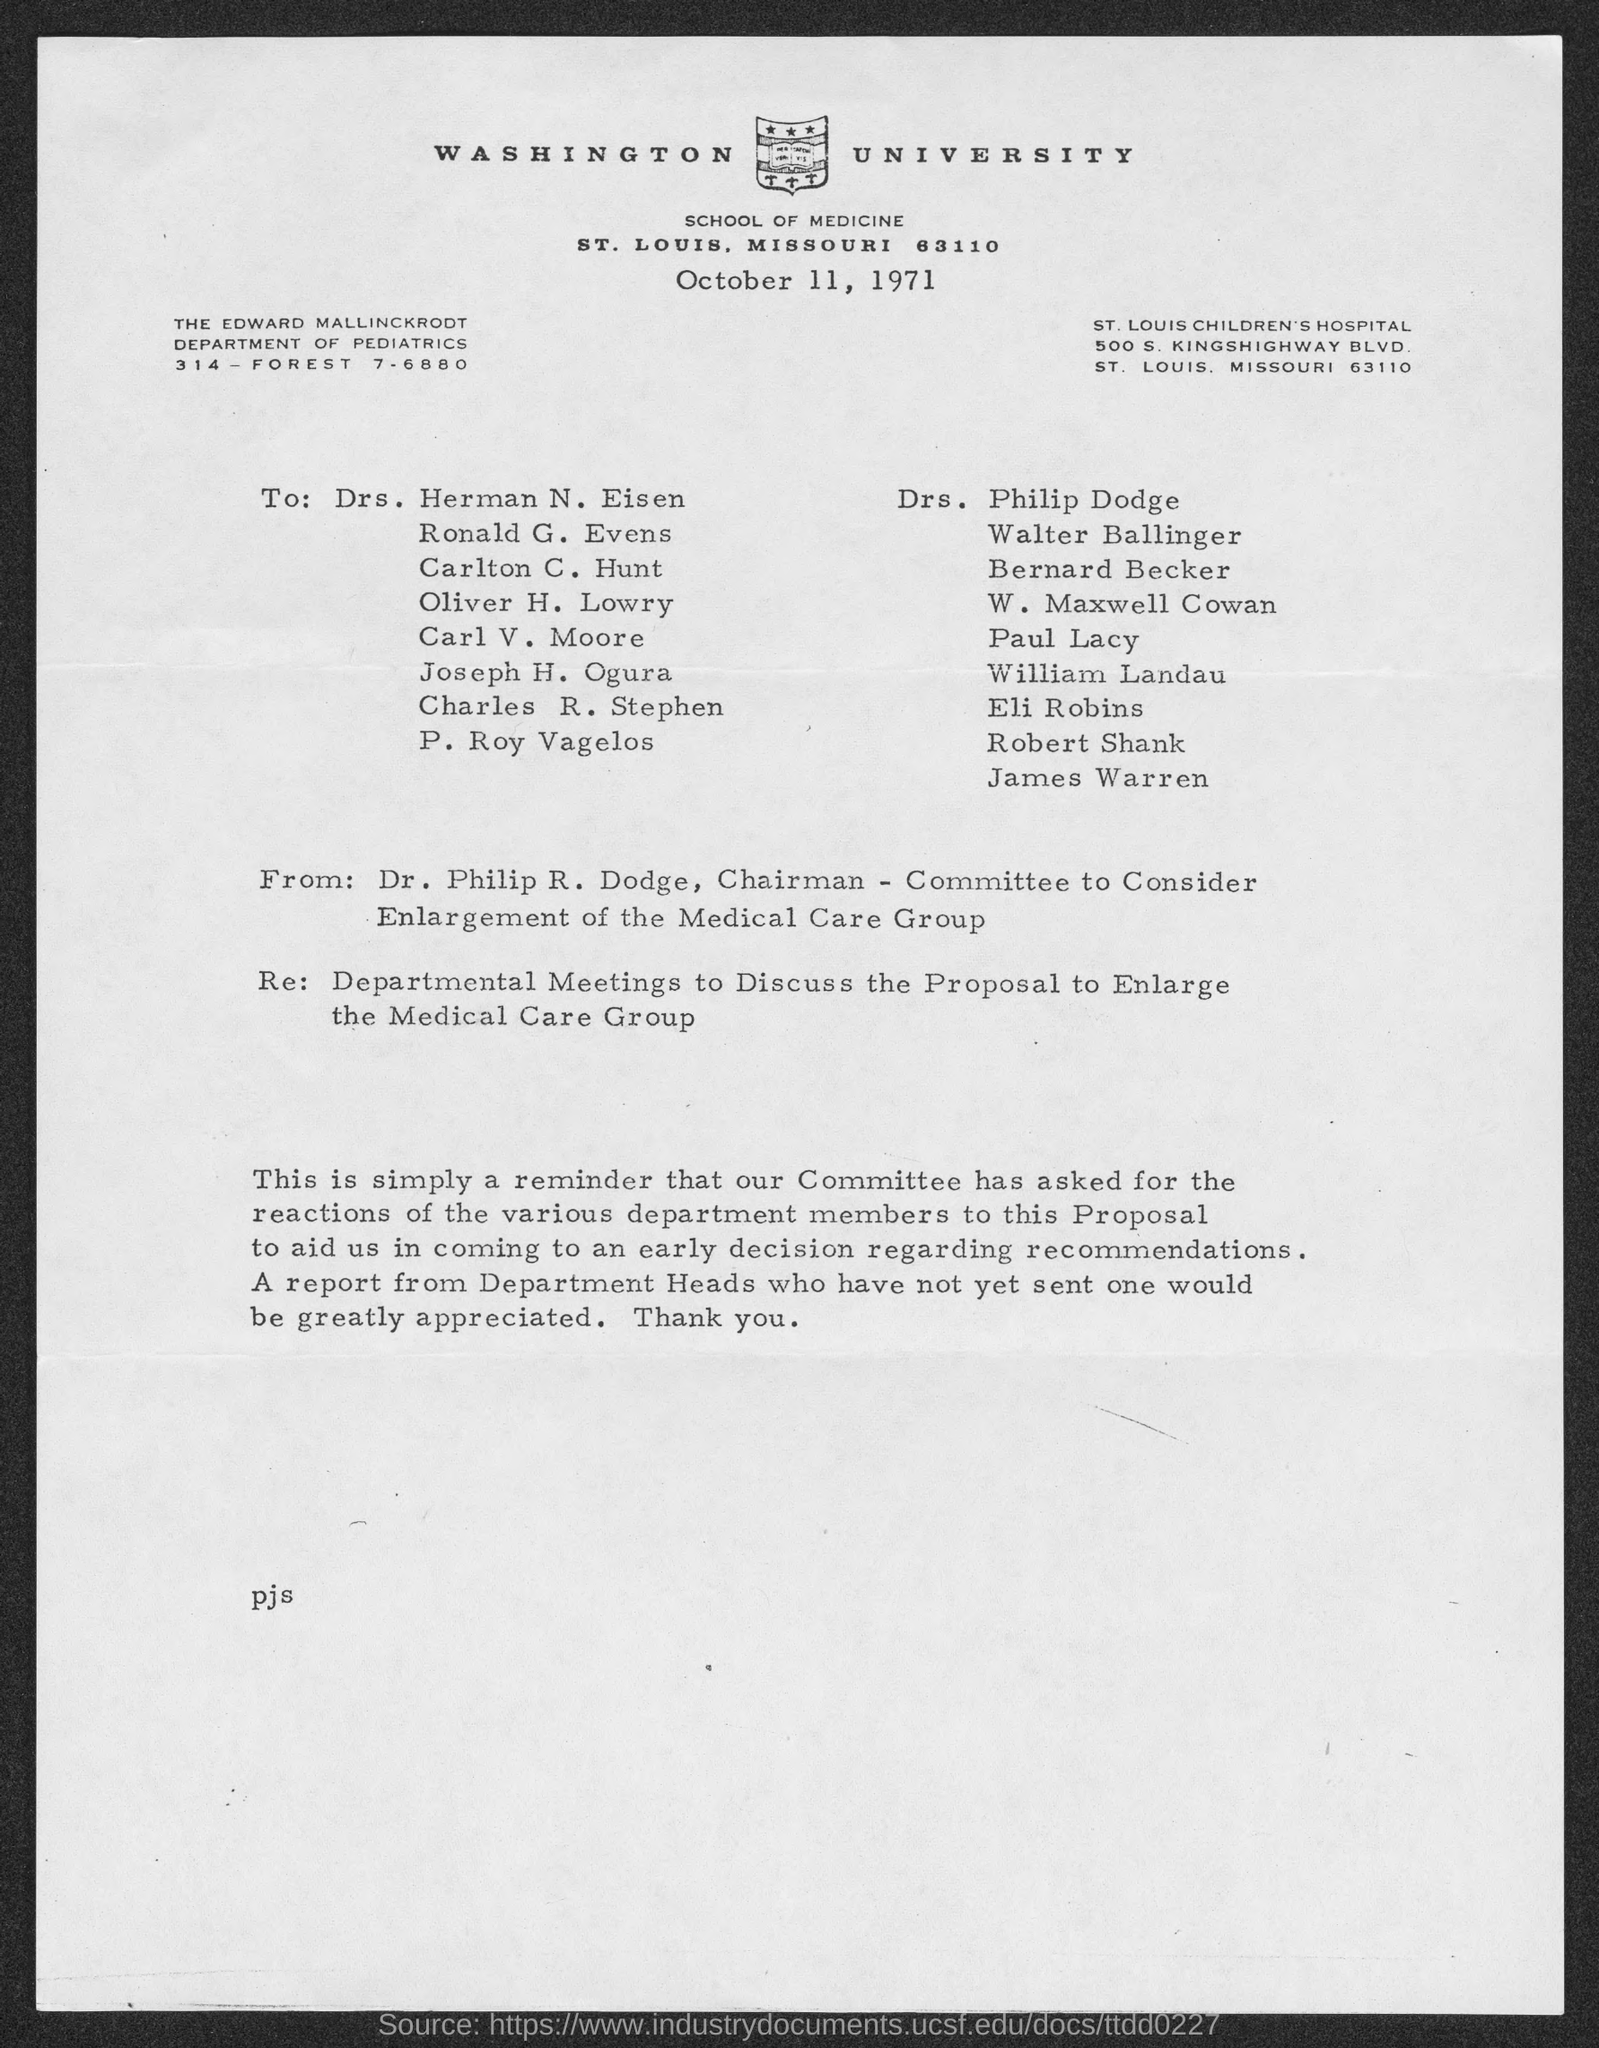Point out several critical features in this image. The letter is from Dr. Philip R. Dodge, the chairman of the Committee to Consider... The document indicates that the date is October 11, 1971. 